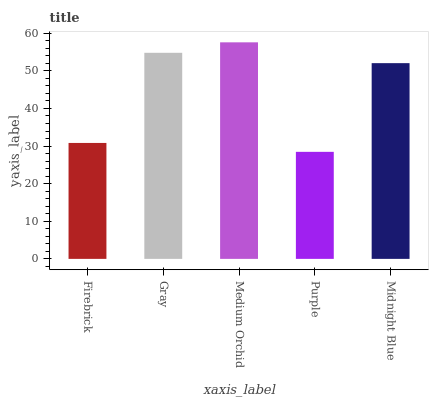Is Purple the minimum?
Answer yes or no. Yes. Is Medium Orchid the maximum?
Answer yes or no. Yes. Is Gray the minimum?
Answer yes or no. No. Is Gray the maximum?
Answer yes or no. No. Is Gray greater than Firebrick?
Answer yes or no. Yes. Is Firebrick less than Gray?
Answer yes or no. Yes. Is Firebrick greater than Gray?
Answer yes or no. No. Is Gray less than Firebrick?
Answer yes or no. No. Is Midnight Blue the high median?
Answer yes or no. Yes. Is Midnight Blue the low median?
Answer yes or no. Yes. Is Purple the high median?
Answer yes or no. No. Is Purple the low median?
Answer yes or no. No. 